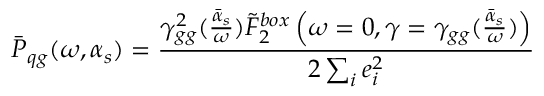<formula> <loc_0><loc_0><loc_500><loc_500>\bar { P } _ { q g } ( \omega , \alpha _ { s } ) = { \frac { \gamma _ { g g } ^ { 2 } ( { \frac { \bar { \alpha } _ { s } } { \omega } } ) \tilde { F } _ { 2 } ^ { b o x } \left ( \omega = 0 , \gamma = \gamma _ { g g } ( { \frac { \bar { \alpha } _ { s } } { \omega } } ) \right ) } { 2 \sum _ { i } e _ { i } ^ { 2 } } }</formula> 